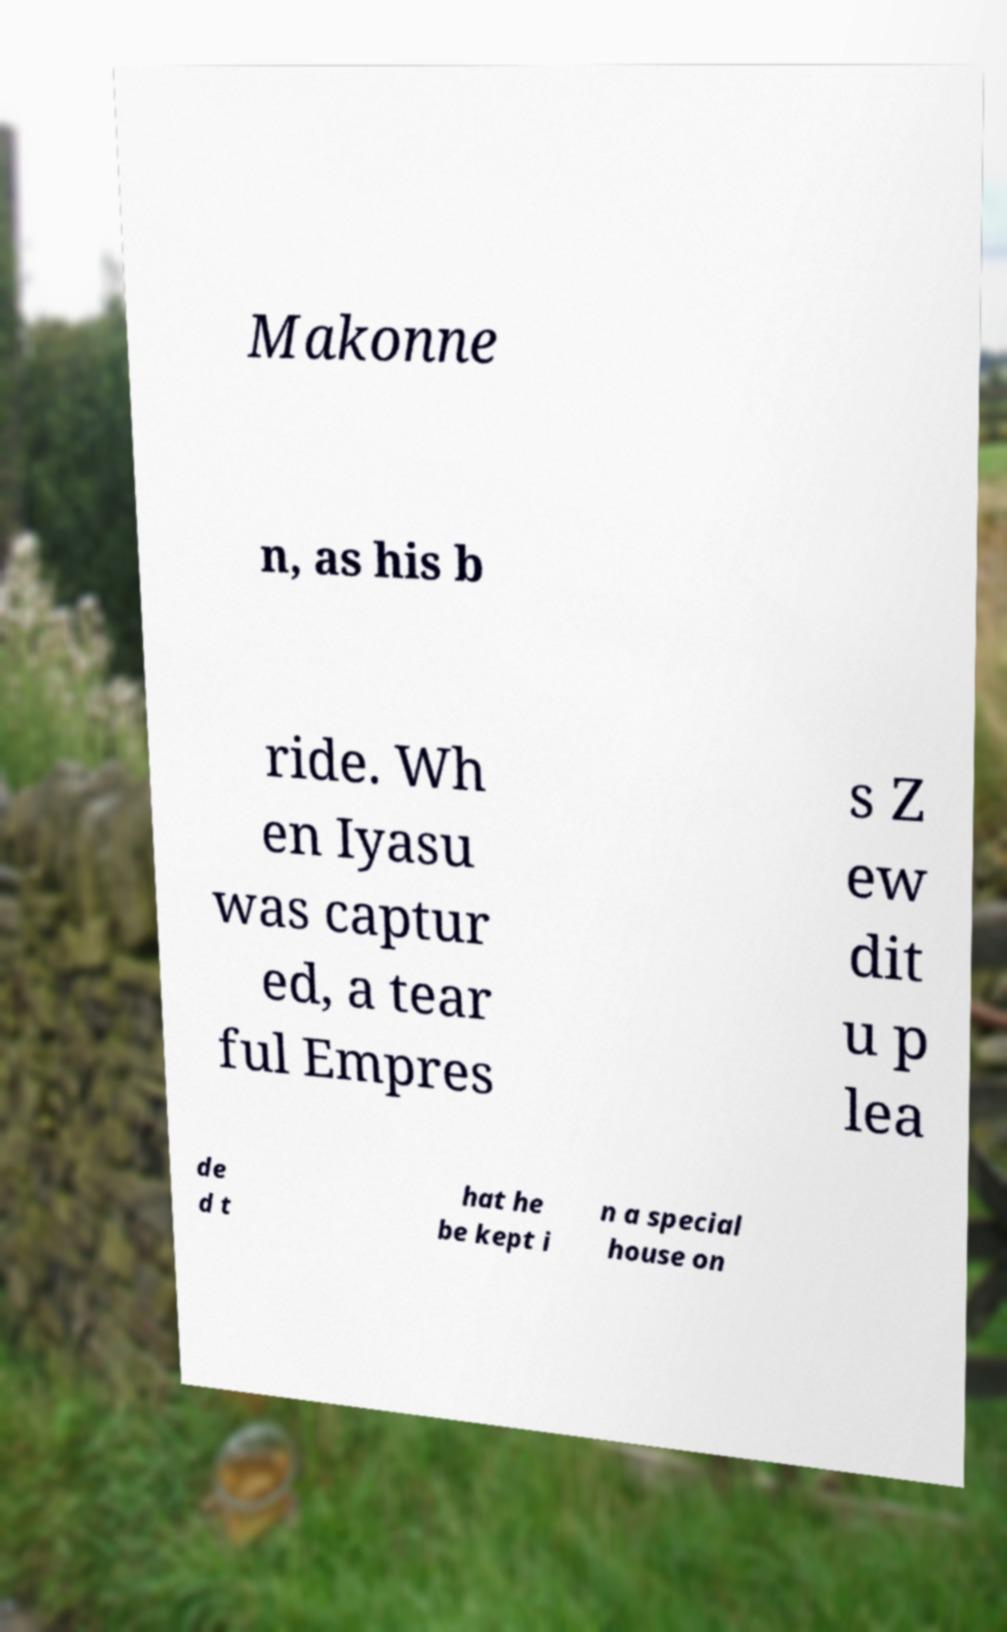Can you read and provide the text displayed in the image?This photo seems to have some interesting text. Can you extract and type it out for me? Makonne n, as his b ride. Wh en Iyasu was captur ed, a tear ful Empres s Z ew dit u p lea de d t hat he be kept i n a special house on 